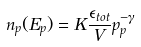<formula> <loc_0><loc_0><loc_500><loc_500>n _ { p } ( E _ { p } ) = K \frac { \epsilon _ { t o t } } { V } p _ { p } ^ { - \gamma }</formula> 